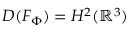<formula> <loc_0><loc_0><loc_500><loc_500>D ( F _ { \Phi } ) = H ^ { 2 } ( \mathbb { R } ^ { 3 } )</formula> 